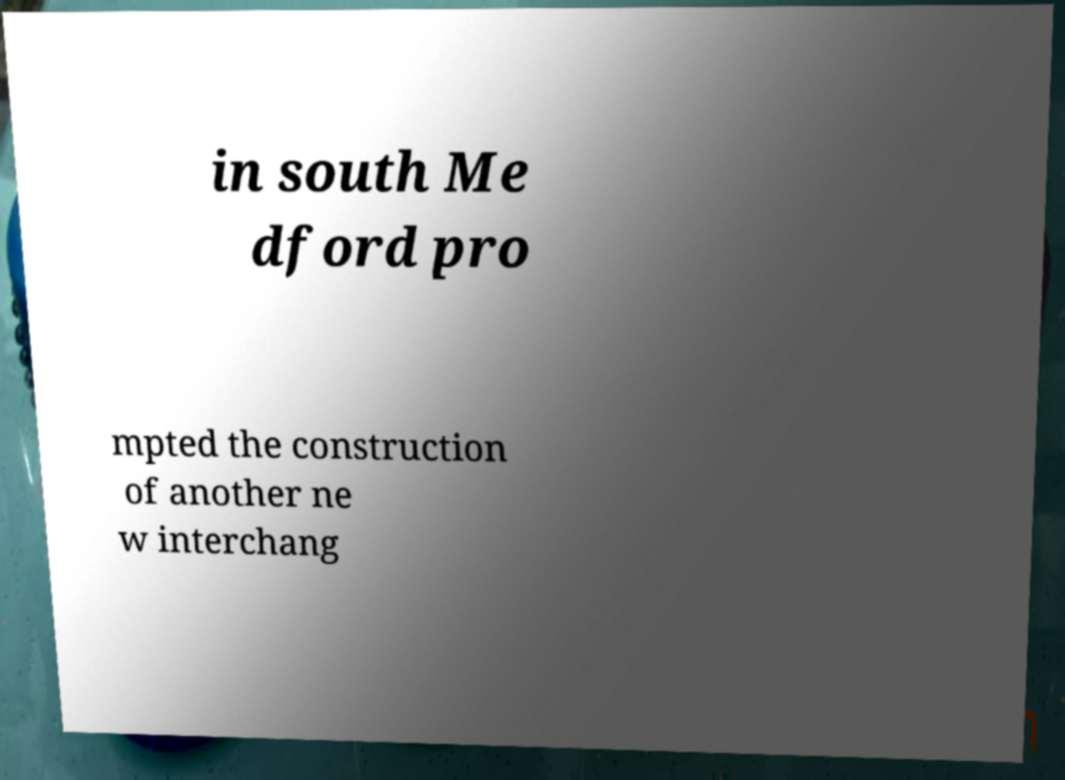What messages or text are displayed in this image? I need them in a readable, typed format. in south Me dford pro mpted the construction of another ne w interchang 